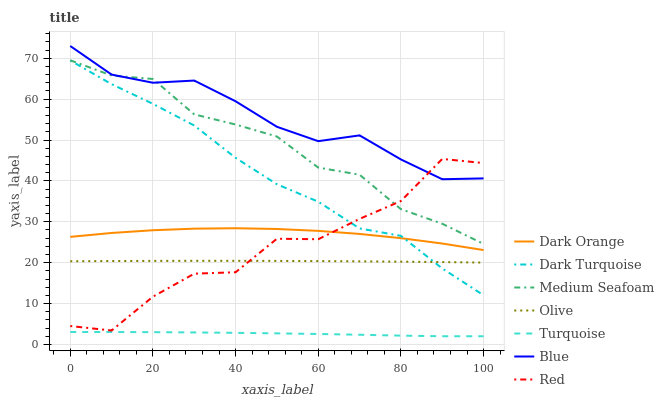Does Turquoise have the minimum area under the curve?
Answer yes or no. Yes. Does Blue have the maximum area under the curve?
Answer yes or no. Yes. Does Dark Orange have the minimum area under the curve?
Answer yes or no. No. Does Dark Orange have the maximum area under the curve?
Answer yes or no. No. Is Olive the smoothest?
Answer yes or no. Yes. Is Red the roughest?
Answer yes or no. Yes. Is Dark Orange the smoothest?
Answer yes or no. No. Is Dark Orange the roughest?
Answer yes or no. No. Does Dark Orange have the lowest value?
Answer yes or no. No. Does Blue have the highest value?
Answer yes or no. Yes. Does Dark Orange have the highest value?
Answer yes or no. No. Is Dark Orange less than Blue?
Answer yes or no. Yes. Is Medium Seafoam greater than Turquoise?
Answer yes or no. Yes. Does Blue intersect Red?
Answer yes or no. Yes. Is Blue less than Red?
Answer yes or no. No. Is Blue greater than Red?
Answer yes or no. No. Does Dark Orange intersect Blue?
Answer yes or no. No. 